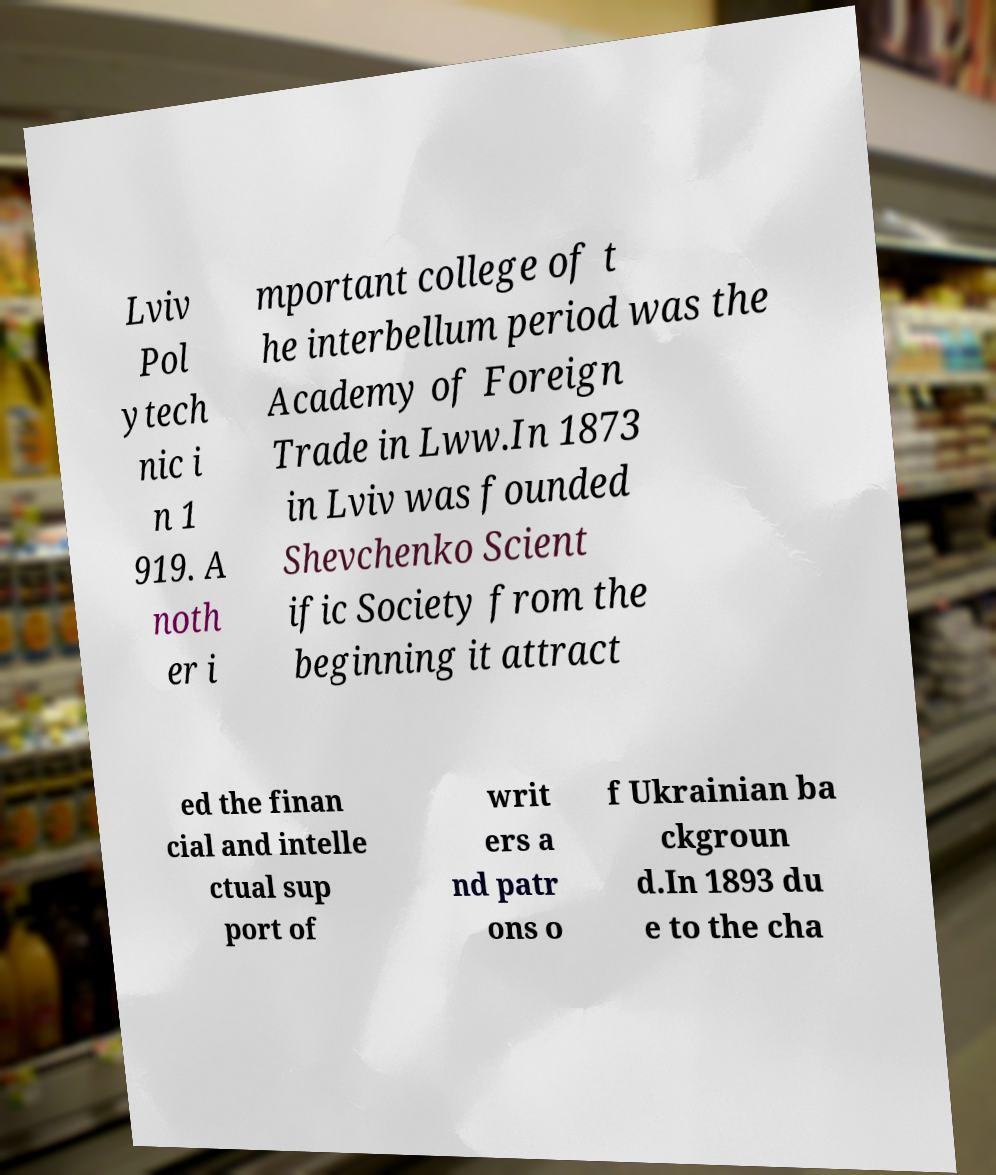Can you accurately transcribe the text from the provided image for me? Lviv Pol ytech nic i n 1 919. A noth er i mportant college of t he interbellum period was the Academy of Foreign Trade in Lww.In 1873 in Lviv was founded Shevchenko Scient ific Society from the beginning it attract ed the finan cial and intelle ctual sup port of writ ers a nd patr ons o f Ukrainian ba ckgroun d.In 1893 du e to the cha 